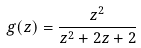Convert formula to latex. <formula><loc_0><loc_0><loc_500><loc_500>g ( z ) = \frac { z ^ { 2 } } { z ^ { 2 } + 2 z + 2 }</formula> 